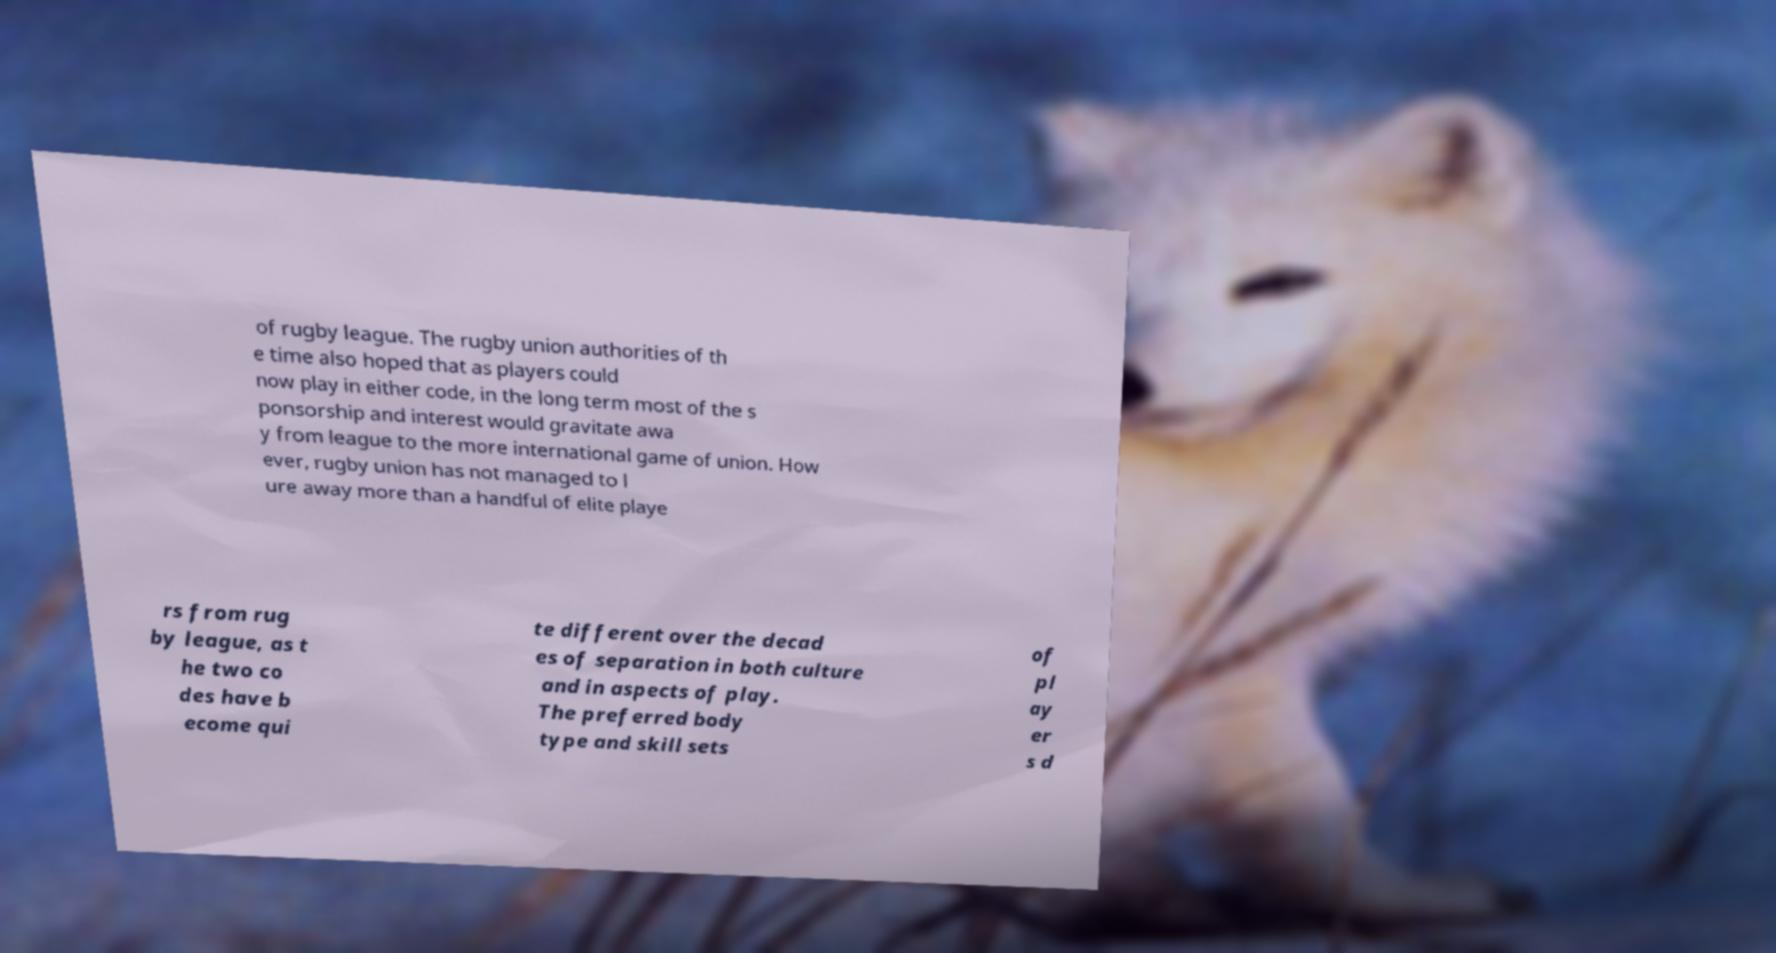I need the written content from this picture converted into text. Can you do that? of rugby league. The rugby union authorities of th e time also hoped that as players could now play in either code, in the long term most of the s ponsorship and interest would gravitate awa y from league to the more international game of union. How ever, rugby union has not managed to l ure away more than a handful of elite playe rs from rug by league, as t he two co des have b ecome qui te different over the decad es of separation in both culture and in aspects of play. The preferred body type and skill sets of pl ay er s d 